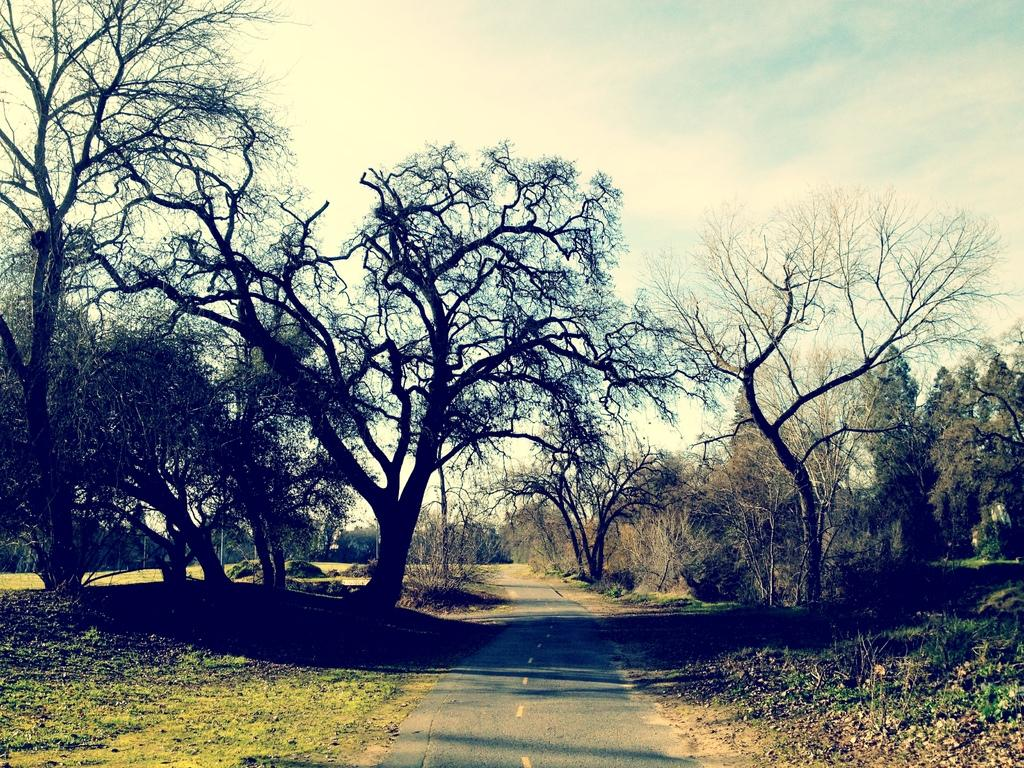What type of vegetation can be seen in the image? There are trees in the image. What is covering the ground in the image? There is grass on the ground in the image. What is the condition of the sky in the image? The sky is cloudy in the image. What type of knife can be seen cutting through the friction in the image? There is no knife or friction present in the image; it features trees, grass, and a cloudy sky. 